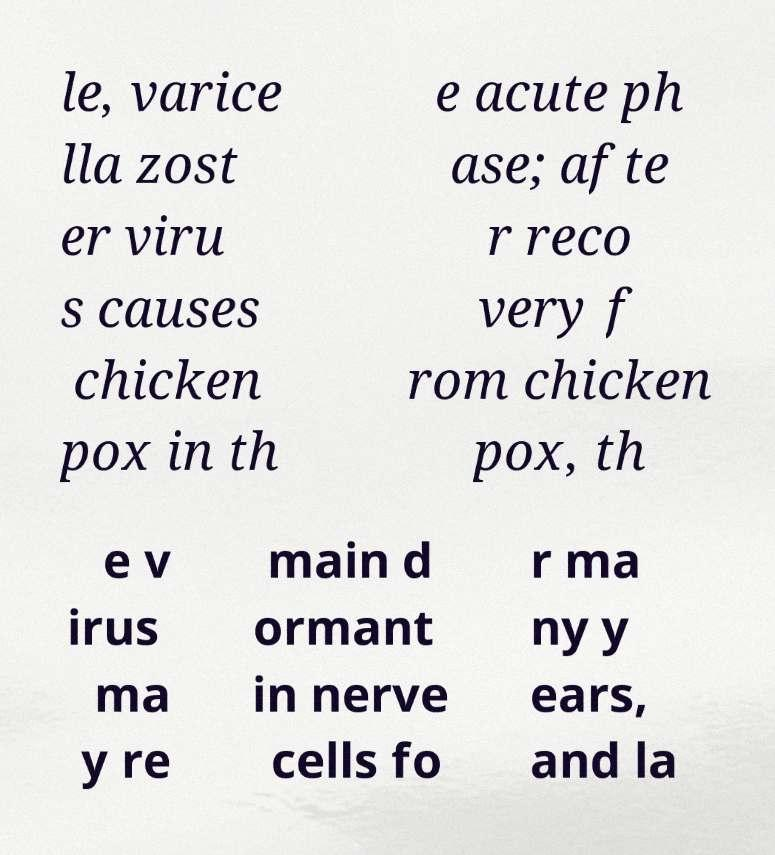I need the written content from this picture converted into text. Can you do that? le, varice lla zost er viru s causes chicken pox in th e acute ph ase; afte r reco very f rom chicken pox, th e v irus ma y re main d ormant in nerve cells fo r ma ny y ears, and la 